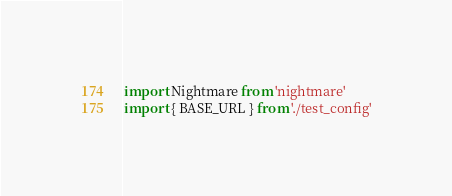Convert code to text. <code><loc_0><loc_0><loc_500><loc_500><_JavaScript_>import Nightmare from 'nightmare'
import { BASE_URL } from './test_config'
</code> 